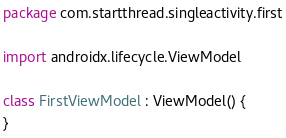Convert code to text. <code><loc_0><loc_0><loc_500><loc_500><_Kotlin_>package com.startthread.singleactivity.first

import androidx.lifecycle.ViewModel

class FirstViewModel : ViewModel() {
}</code> 